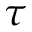<formula> <loc_0><loc_0><loc_500><loc_500>\tau</formula> 